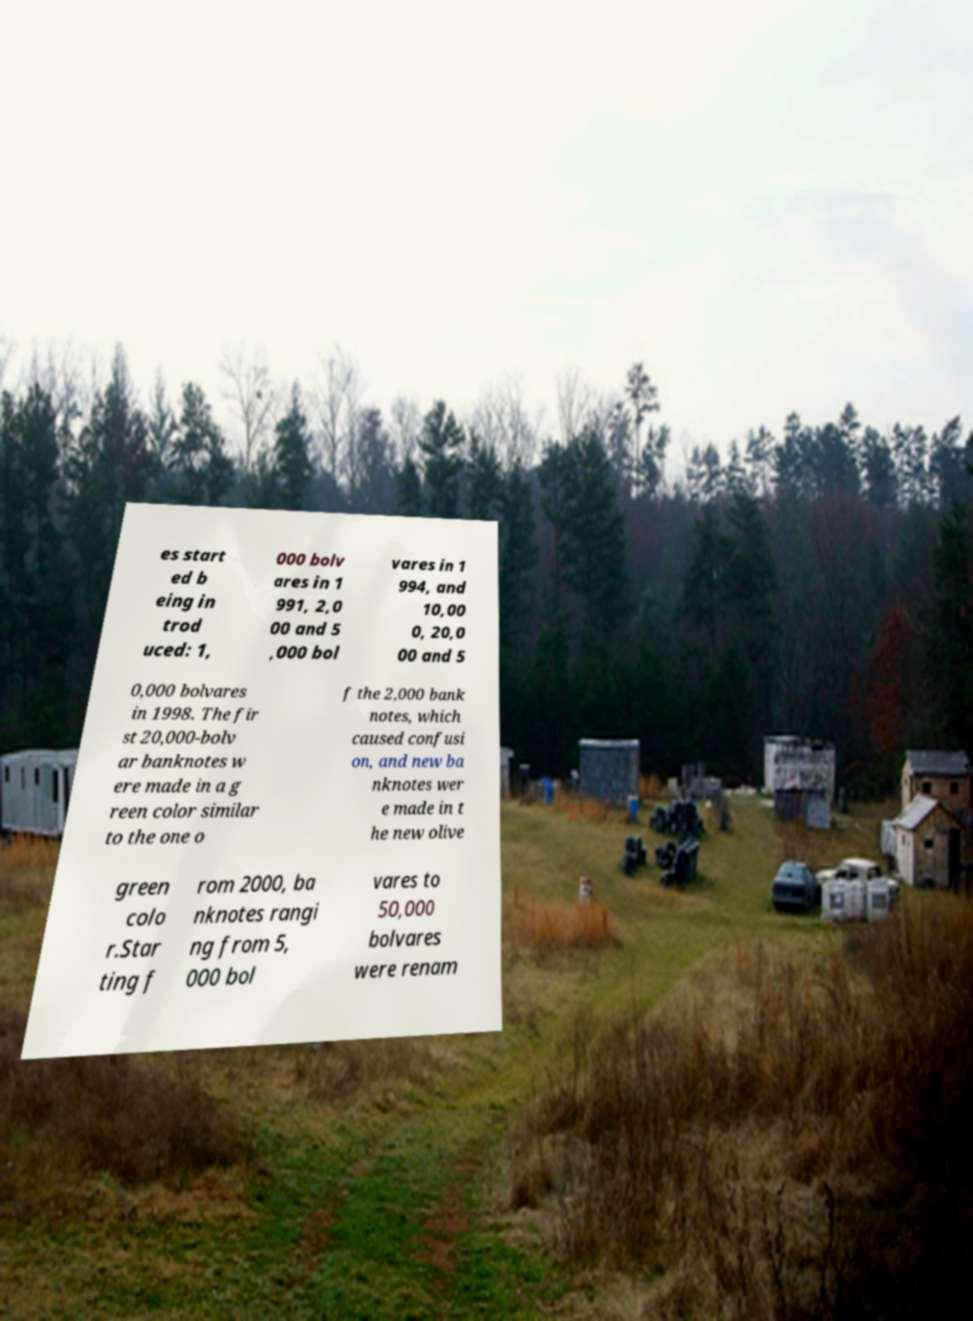What messages or text are displayed in this image? I need them in a readable, typed format. es start ed b eing in trod uced: 1, 000 bolv ares in 1 991, 2,0 00 and 5 ,000 bol vares in 1 994, and 10,00 0, 20,0 00 and 5 0,000 bolvares in 1998. The fir st 20,000-bolv ar banknotes w ere made in a g reen color similar to the one o f the 2,000 bank notes, which caused confusi on, and new ba nknotes wer e made in t he new olive green colo r.Star ting f rom 2000, ba nknotes rangi ng from 5, 000 bol vares to 50,000 bolvares were renam 